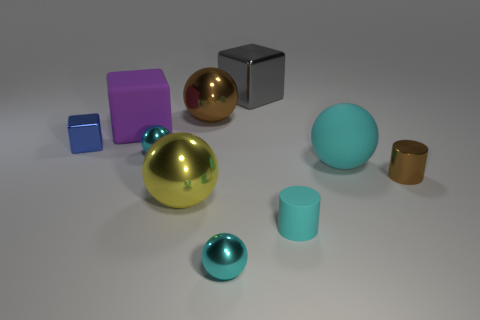Are there fewer tiny metal spheres that are behind the tiny blue object than big red spheres?
Ensure brevity in your answer.  No. Are there any metal things that have the same size as the brown metallic cylinder?
Offer a terse response. Yes. Is the color of the matte cube the same as the large metallic ball that is in front of the tiny brown shiny cylinder?
Your response must be concise. No. How many purple objects are in front of the small cyan metal thing that is behind the tiny metal cylinder?
Provide a short and direct response. 0. What is the color of the cylinder behind the big shiny ball that is in front of the matte sphere?
Keep it short and to the point. Brown. There is a big object that is left of the big brown shiny ball and in front of the large matte block; what material is it made of?
Provide a short and direct response. Metal. Is there another object of the same shape as the large brown shiny object?
Ensure brevity in your answer.  Yes. Does the large matte thing to the left of the big brown ball have the same shape as the large brown metal thing?
Provide a short and direct response. No. How many brown metallic objects are both in front of the purple thing and behind the big purple cube?
Provide a short and direct response. 0. What is the shape of the brown thing that is right of the brown metal ball?
Give a very brief answer. Cylinder. 